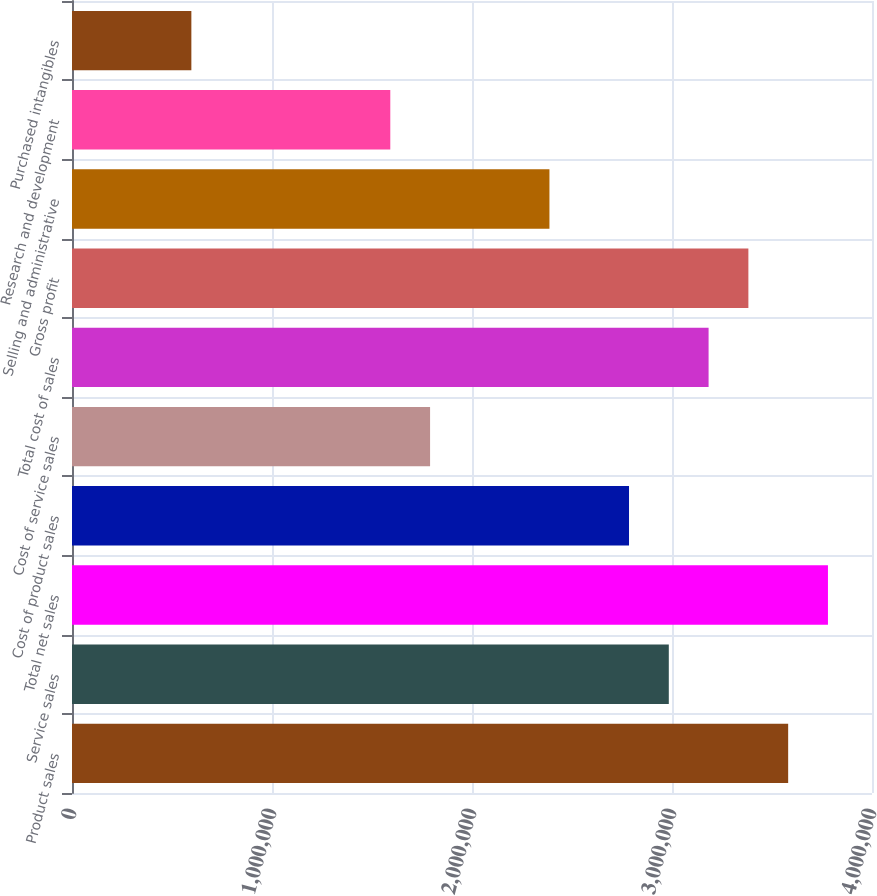Convert chart to OTSL. <chart><loc_0><loc_0><loc_500><loc_500><bar_chart><fcel>Product sales<fcel>Service sales<fcel>Total net sales<fcel>Cost of product sales<fcel>Cost of service sales<fcel>Total cost of sales<fcel>Gross profit<fcel>Selling and administrative<fcel>Research and development<fcel>Purchased intangibles<nl><fcel>3.58082e+06<fcel>2.98401e+06<fcel>3.77975e+06<fcel>2.78508e+06<fcel>1.79041e+06<fcel>3.18295e+06<fcel>3.38188e+06<fcel>2.38721e+06<fcel>1.59148e+06<fcel>596807<nl></chart> 